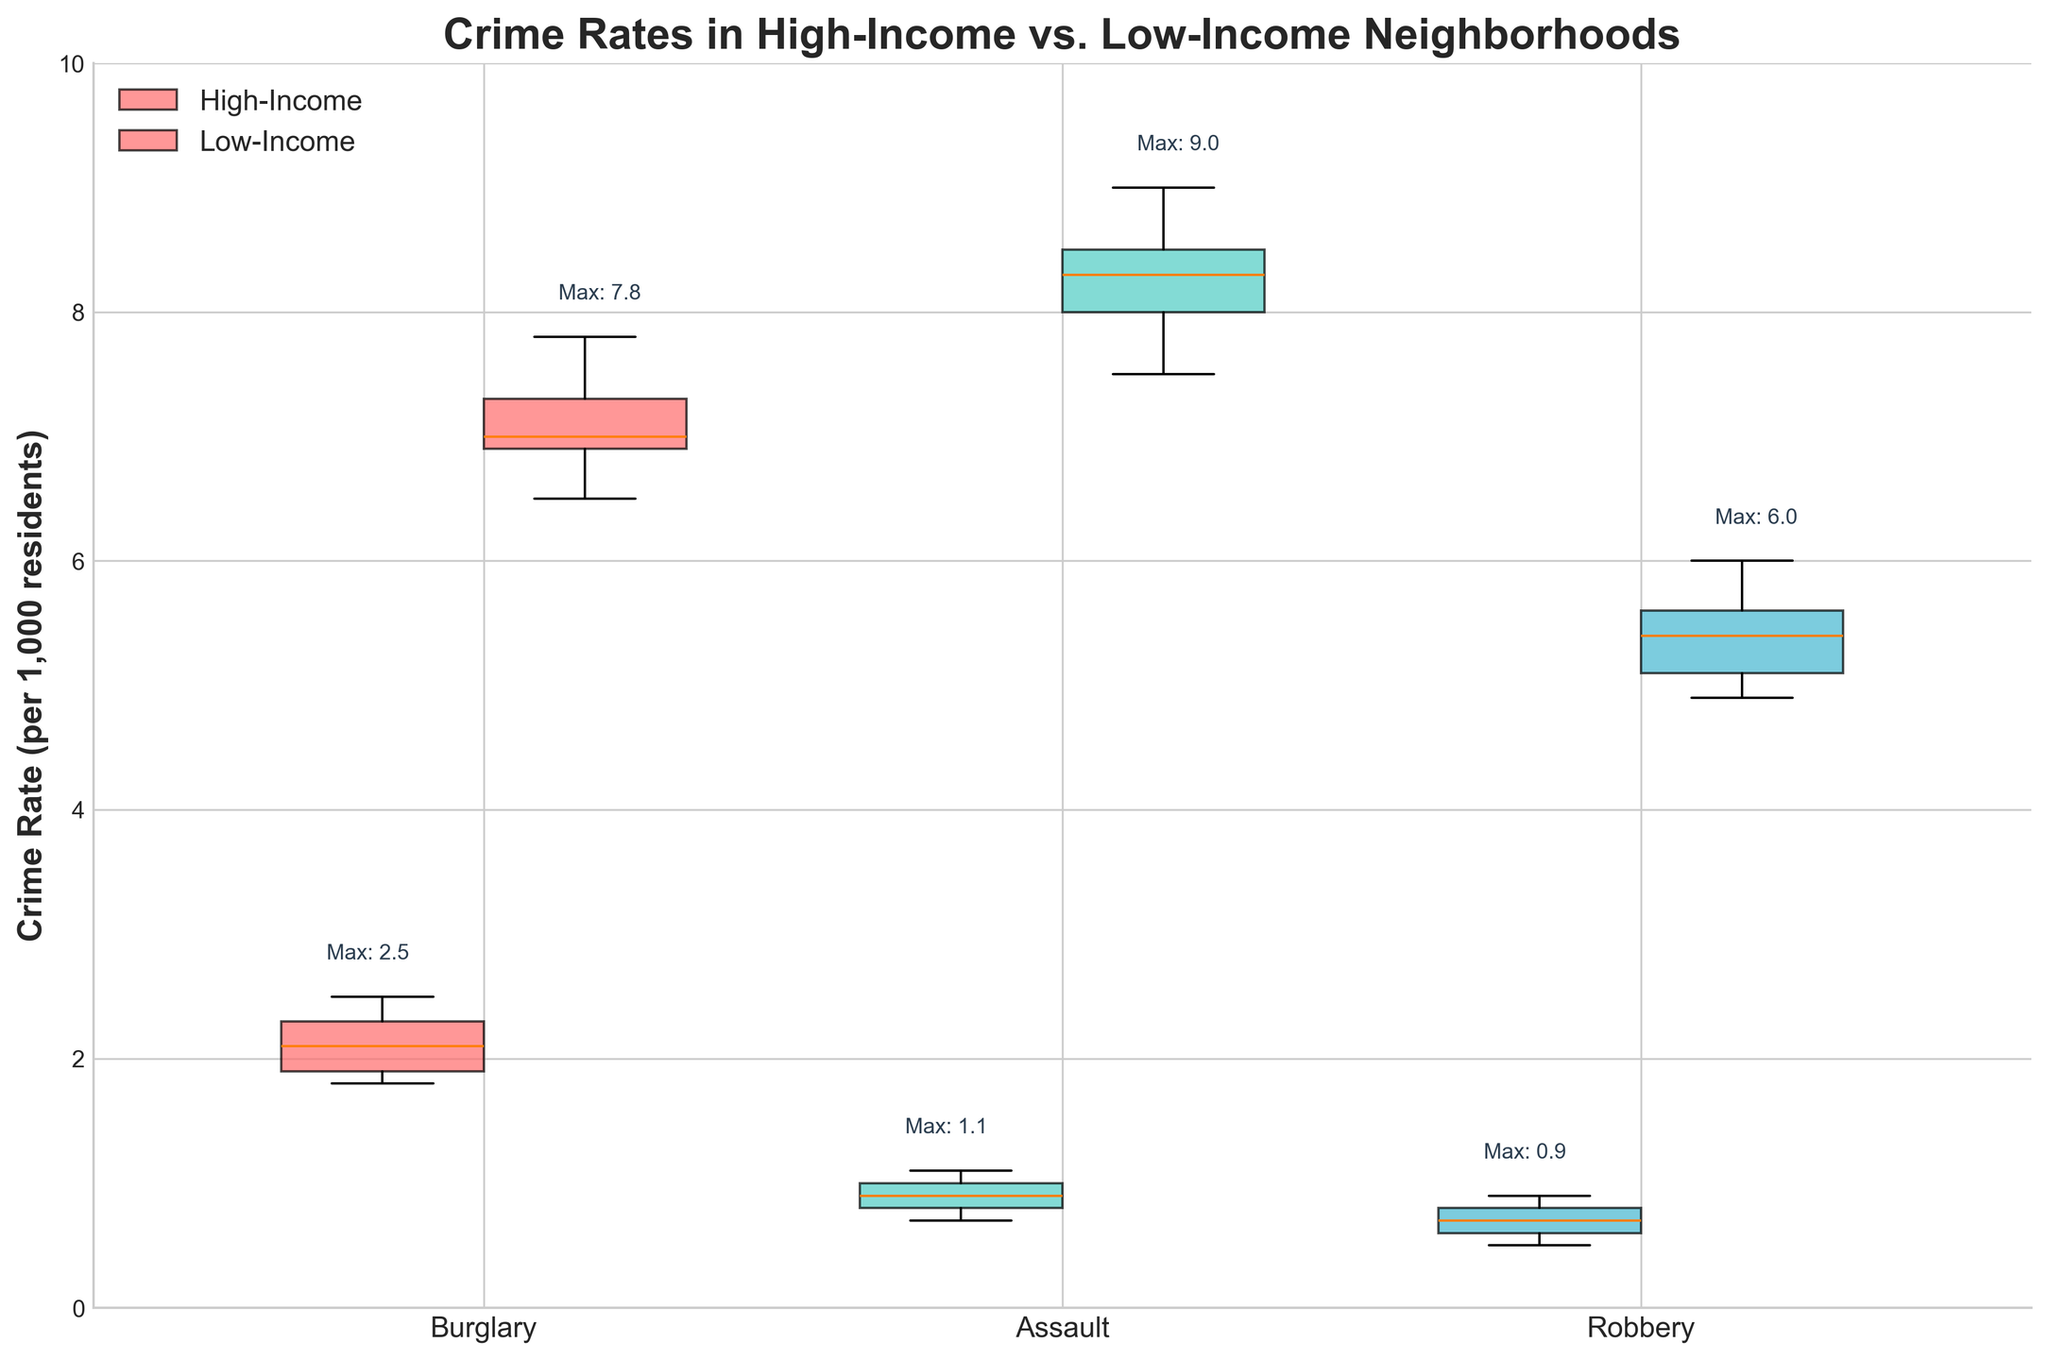What is the title of the figure? The title is usually at the top of the figure, setting the context for what the plot represents.
Answer: Crime Rates in High-Income vs. Low-Income Neighborhoods What are the three types of crime rates represented on the x-axis? Examine the labels on the x-axis. They identify the categories being compared.
Answer: Burglary, Assault, Robbery What is the range of the y-axis? The y-axis typically represents the scale of the data. Check the axis to find the minimum and maximum values.
Answer: 0 to 10 Which crime type has the highest maximum value for low-income neighborhoods? Look at the positions above the box plots showing the maximum values for each crime type in low-income neighborhoods.
Answer: Assault Which income level has a higher median crime rate for Burglary? Identify the line in the middle of the box for each income level's Burglary category. The median is represented by this line.
Answer: Low-Income What are the colors used to differentiate between the crime types? Examine the colors in the boxes of each crime type; there will be a specific color scheme to distinguish them.
Answer: Red, Teal, Blue What is the difference in the maximum values of Assault between high-income and low-income neighborhoods? Find the maximum values above the boxes for Assault in both income levels and subtract them.
Answer: 9.0 - 1.1 = 7.9 Which income level has a generally higher crime rate across all types? Compare the general positioning of the box plots between the two income levels for all crime types.
Answer: Low-Income For which crime type is the difference between the median crime rates of high-income and low-income neighborhoods the largest? Observe the middle lines (medians) in the box plots for each crime type and calculate the differences.
Answer: Assault How does the variation in crime rates for Robbery compare between high-income and low-income neighborhoods? Compare the spread (interquartile range) of the box plots for Robbery for both income levels.
Answer: Higher in Low-Income What is the box plot element at the middle value of each distribution called? Review that box plots include an element that marks the center of the data distribution.
Answer: Median 